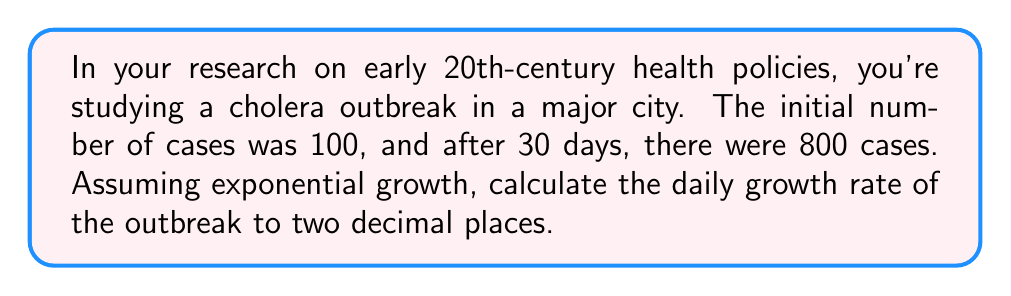Give your solution to this math problem. Let's approach this step-by-step using the exponential growth formula:

1) The exponential growth formula is:
   $A = P(1 + r)^t$
   Where:
   $A$ = Final amount
   $P$ = Initial amount
   $r$ = Daily growth rate
   $t$ = Number of days

2) We know:
   $P = 100$ (initial cases)
   $A = 800$ (cases after 30 days)
   $t = 30$ days

3) Let's substitute these values into the formula:
   $800 = 100(1 + r)^{30}$

4) Divide both sides by 100:
   $8 = (1 + r)^{30}$

5) Take the 30th root of both sides:
   $\sqrt[30]{8} = 1 + r$

6) Subtract 1 from both sides:
   $\sqrt[30]{8} - 1 = r$

7) Calculate:
   $r = \sqrt[30]{8} - 1 \approx 0.0683$

8) Convert to a percentage and round to two decimal places:
   $r \approx 6.83\%$
Answer: 6.83% 